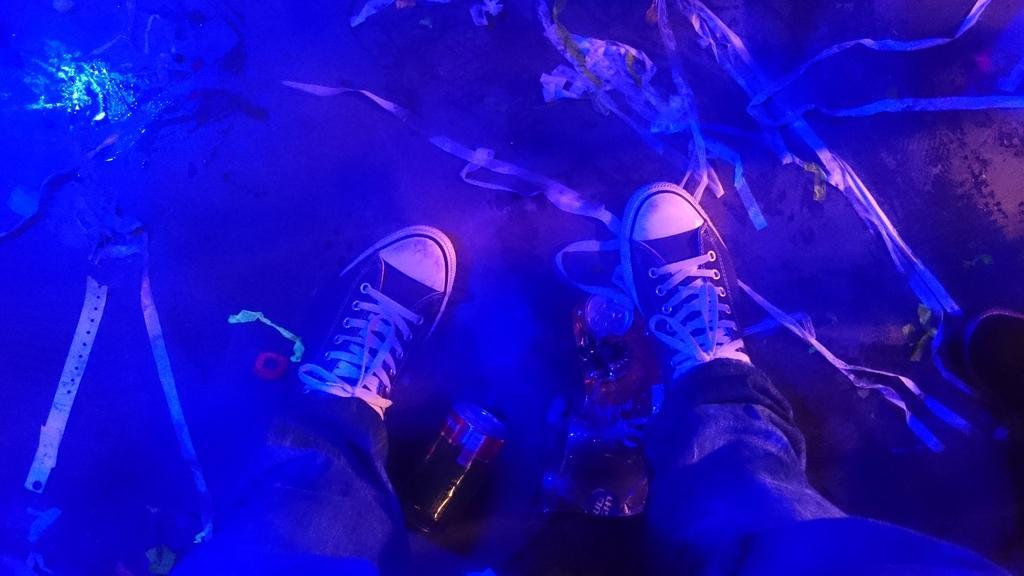How would you summarize this image in a sentence or two? This picture contains the legs of the human who is wearing shoes. Beside the leg, we see a coke bottle. In the background, it is blue in color. 